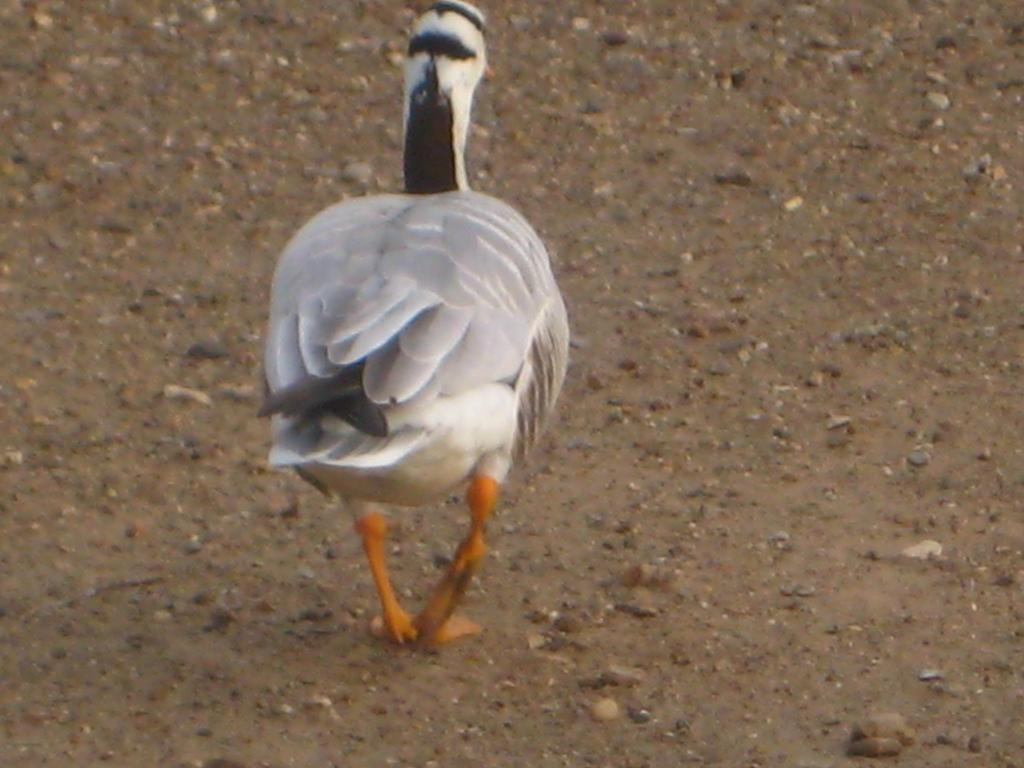What type of animal is present in the image? There is a bird in the image. Where is the bird located? The bird is standing on a mud path. What colors can be seen on the bird? The bird has a white color, with some black color on its tail and near its neck. Is the bird bleeding in the image? There is no indication of blood or injury on the bird in the image. What type of writer is present in the image? There is no writer present in the image; it features a bird standing on a mud path. 